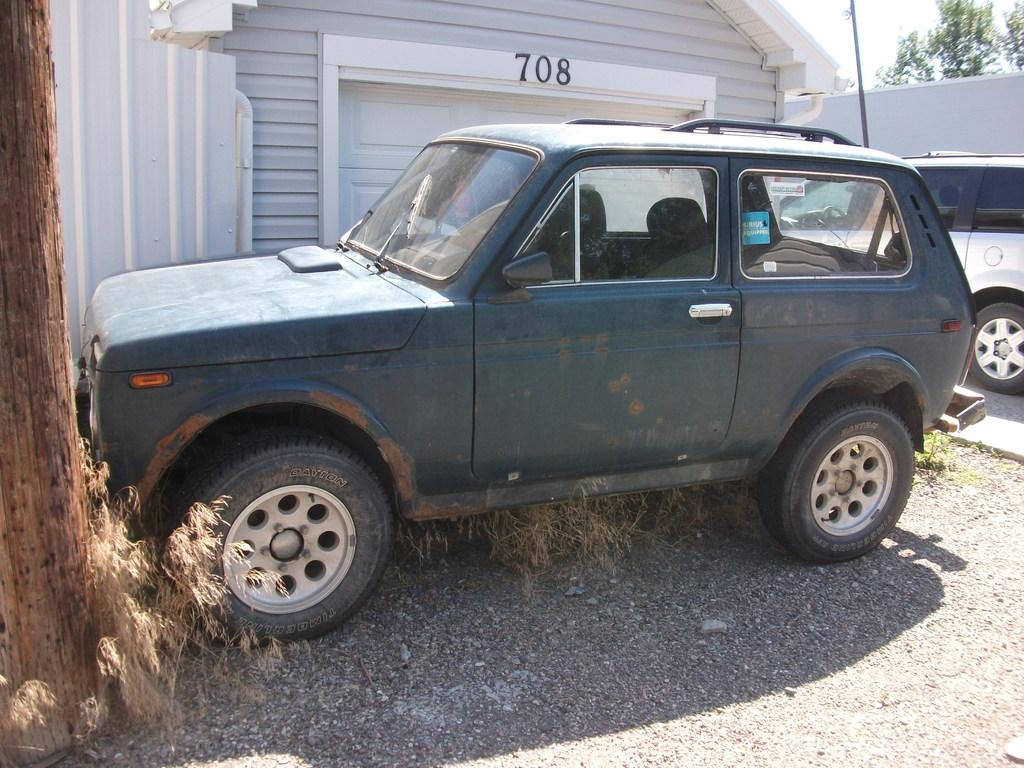Provide a one-sentence caption for the provided image. A dark blue jeep parked in front of a garage with 708 above it. 